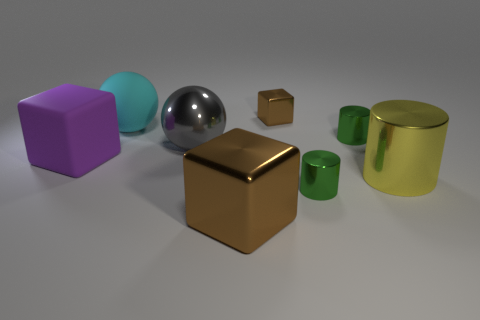The tiny brown object that is the same material as the large gray thing is what shape?
Offer a terse response. Cube. Are there any other things that are the same color as the big rubber ball?
Give a very brief answer. No. How many big cyan balls are behind the rubber thing that is in front of the small cylinder that is behind the purple object?
Offer a terse response. 1. What number of cyan objects are small matte things or big spheres?
Provide a short and direct response. 1. There is a purple block; does it have the same size as the brown shiny object in front of the yellow object?
Ensure brevity in your answer.  Yes. There is a cyan thing that is the same shape as the big gray metal object; what is its material?
Provide a succinct answer. Rubber. How many other things are there of the same size as the rubber cube?
Give a very brief answer. 4. There is a small green thing in front of the metallic sphere that is left of the green thing that is behind the gray object; what is its shape?
Your response must be concise. Cylinder. What is the shape of the object that is to the left of the small brown cube and in front of the large purple matte block?
Provide a succinct answer. Cube. How many things are small yellow matte balls or metal things behind the big metal cylinder?
Offer a very short reply. 3. 